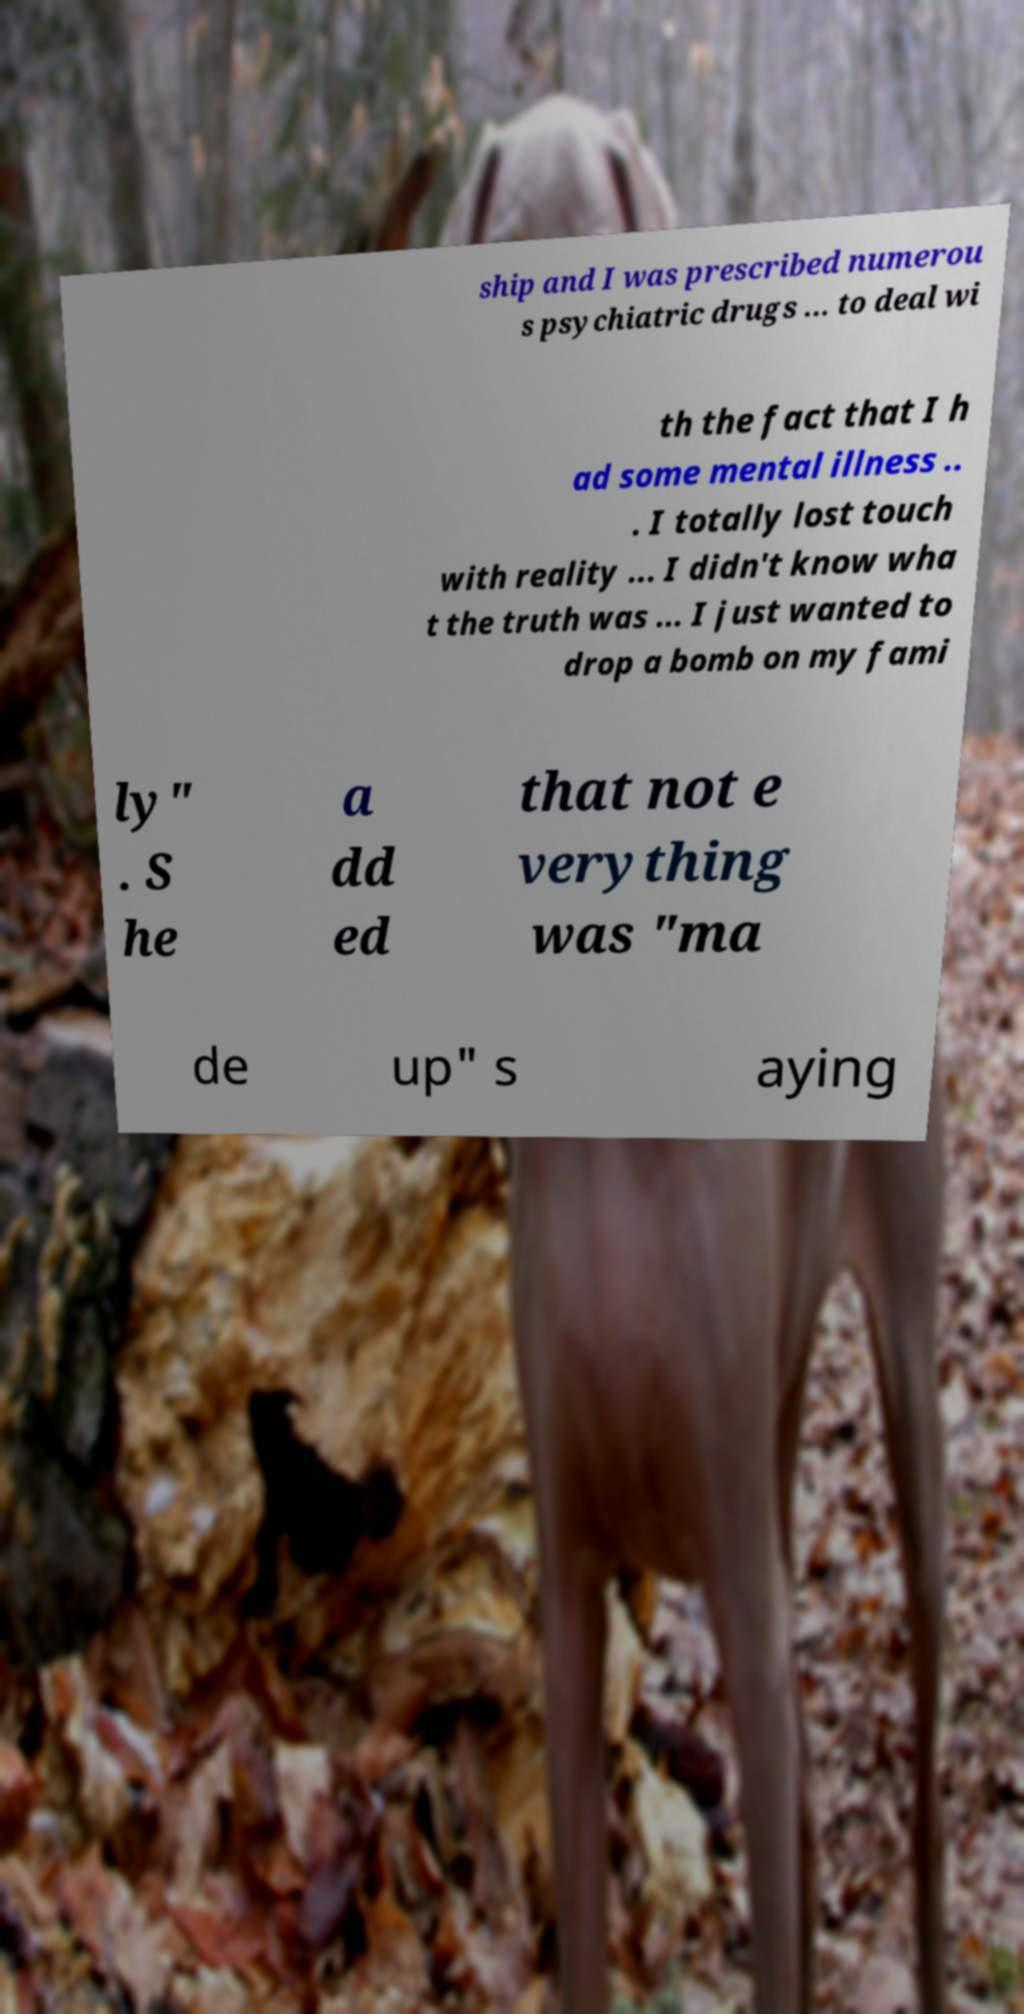There's text embedded in this image that I need extracted. Can you transcribe it verbatim? ship and I was prescribed numerou s psychiatric drugs ... to deal wi th the fact that I h ad some mental illness .. . I totally lost touch with reality ... I didn't know wha t the truth was ... I just wanted to drop a bomb on my fami ly" . S he a dd ed that not e verything was "ma de up" s aying 